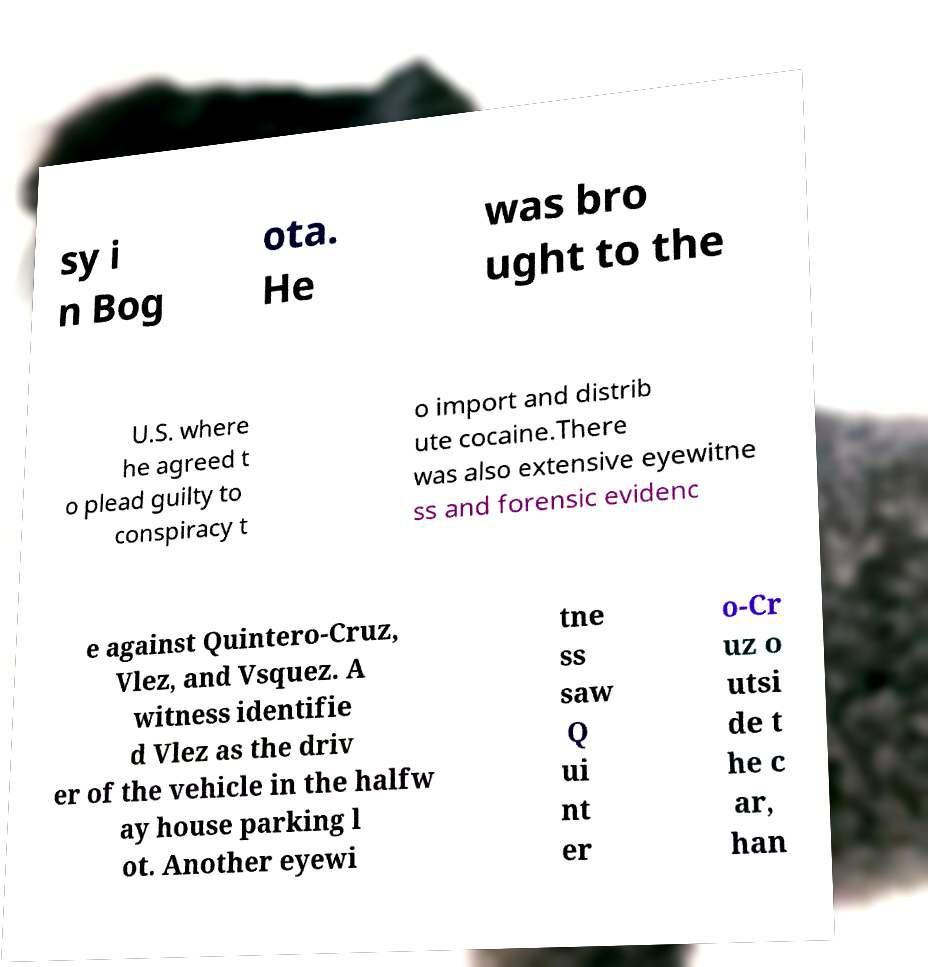Could you extract and type out the text from this image? sy i n Bog ota. He was bro ught to the U.S. where he agreed t o plead guilty to conspiracy t o import and distrib ute cocaine.There was also extensive eyewitne ss and forensic evidenc e against Quintero-Cruz, Vlez, and Vsquez. A witness identifie d Vlez as the driv er of the vehicle in the halfw ay house parking l ot. Another eyewi tne ss saw Q ui nt er o-Cr uz o utsi de t he c ar, han 